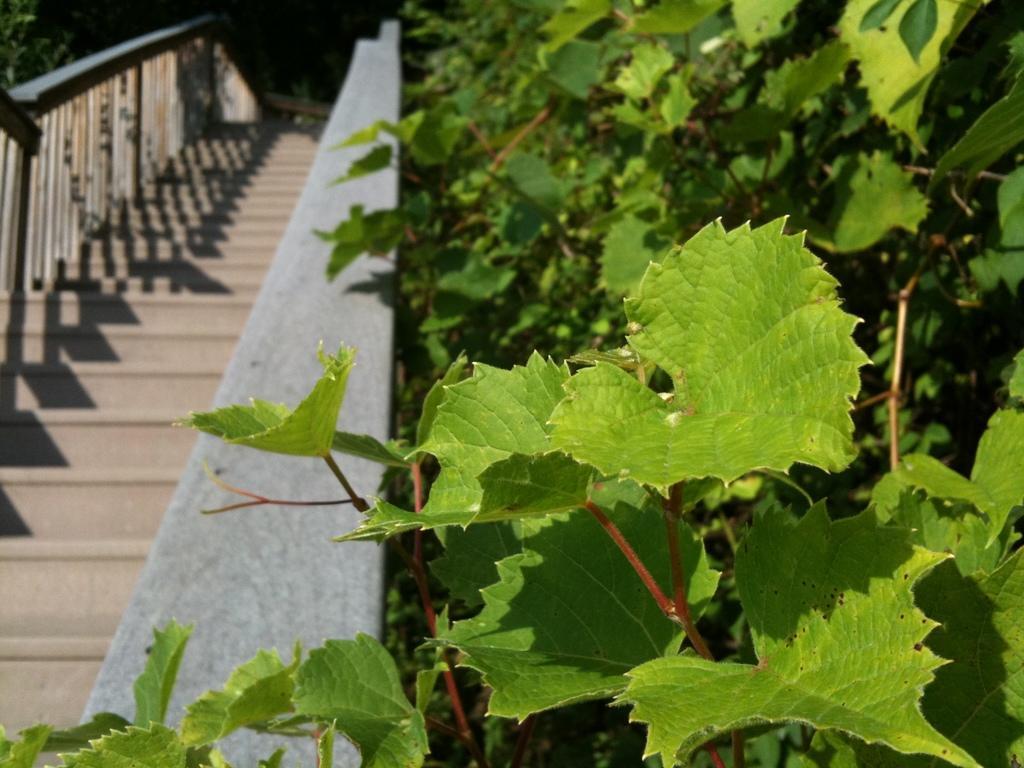How would you summarize this image in a sentence or two? In this picture I can see number of plants in front and on the left side of this picture, I can see the steps. 